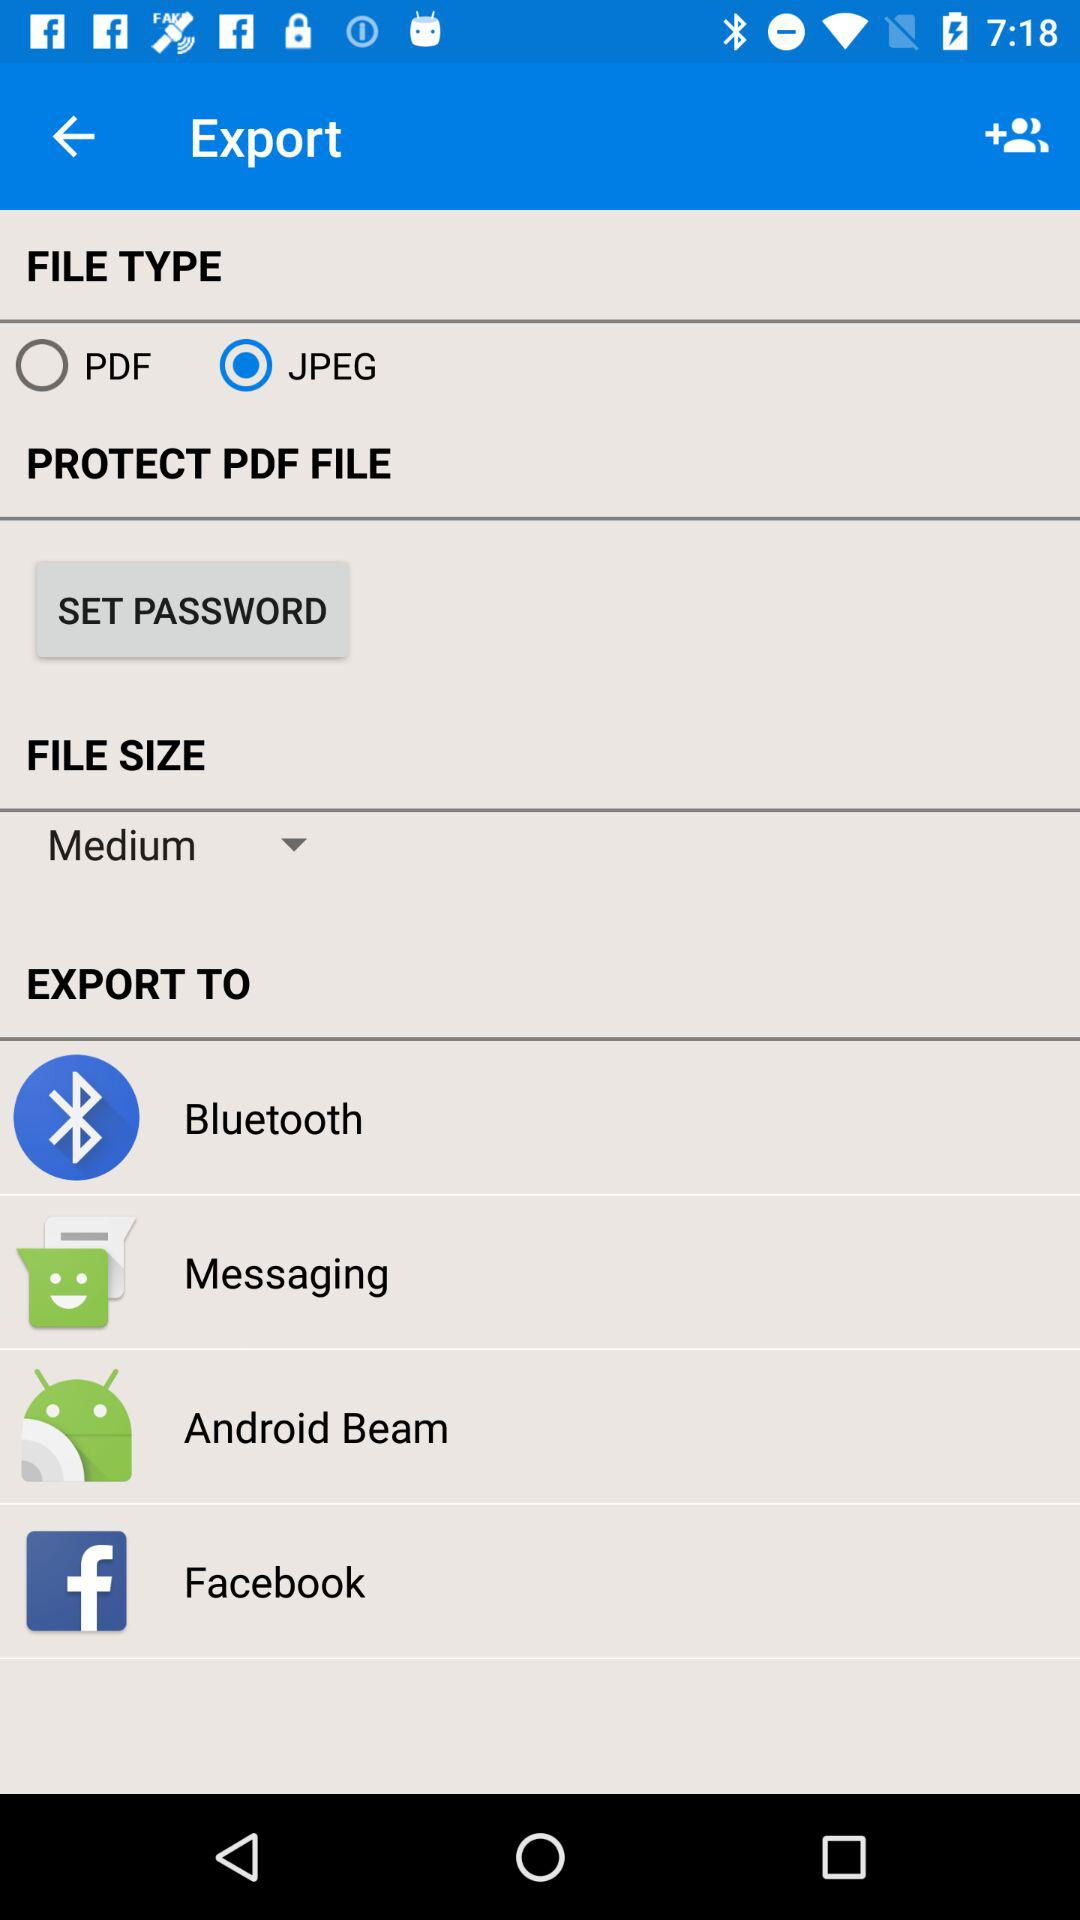How many export destinations are available?
Answer the question using a single word or phrase. 4 